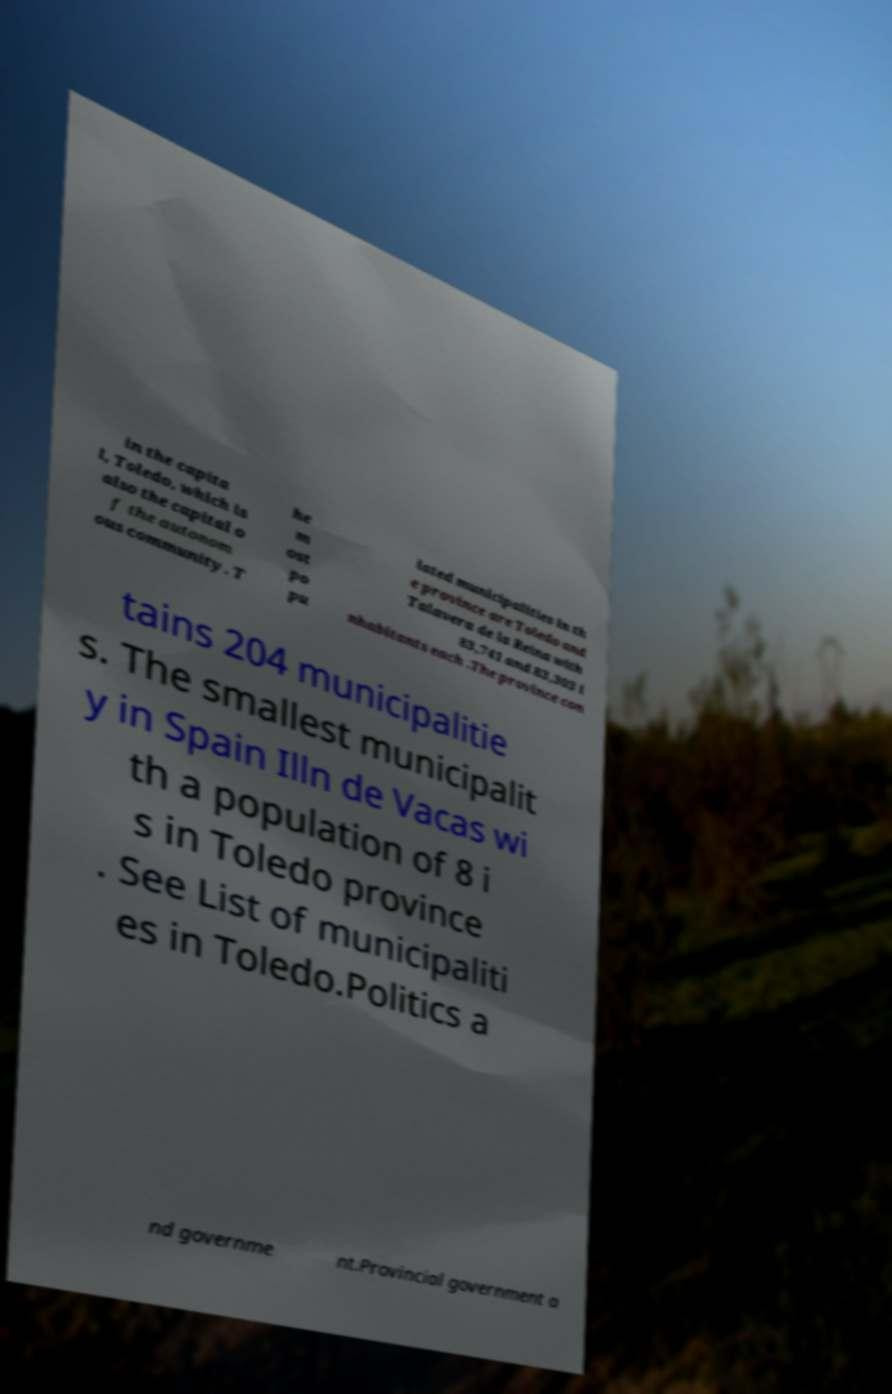There's text embedded in this image that I need extracted. Can you transcribe it verbatim? in the capita l, Toledo, which is also the capital o f the autonom ous community. T he m ost po pu lated municipalities in th e province are Toledo and Talavera de la Reina with 83,741 and 83,303 i nhabitants each .The province con tains 204 municipalitie s. The smallest municipalit y in Spain Illn de Vacas wi th a population of 8 i s in Toledo province . See List of municipaliti es in Toledo.Politics a nd governme nt.Provincial government a 